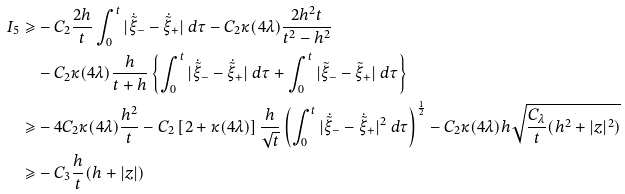<formula> <loc_0><loc_0><loc_500><loc_500>I _ { 5 } \geqslant & - C _ { 2 } \frac { 2 h } t \int ^ { t } _ { 0 } | \dot { \tilde { \xi } } _ { - } - \dot { \tilde { \xi } } _ { + } | \ d \tau - C _ { 2 } \kappa ( 4 \lambda ) \frac { 2 h ^ { 2 } t } { t ^ { 2 } - h ^ { 2 } } \\ & - C _ { 2 } \kappa ( 4 \lambda ) \frac { h } { t + h } \left \{ \int ^ { t } _ { 0 } | \dot { \tilde { \xi } } _ { - } - \dot { \tilde { \xi } } _ { + } | \ d \tau + \int ^ { t } _ { 0 } | \tilde { \xi } _ { - } - \tilde { \xi } _ { + } | \ d \tau \right \} \\ \geqslant & - 4 C _ { 2 } \kappa ( 4 \lambda ) \frac { h ^ { 2 } } { t } - C _ { 2 } \left [ 2 + \kappa ( 4 \lambda ) \right ] \frac { h } { \sqrt { t } } \left ( \int ^ { t } _ { 0 } | \dot { \tilde { \xi } } _ { - } - \dot { \tilde { \xi } } _ { + } | ^ { 2 } \ d \tau \right ) ^ { \frac { 1 } { 2 } } - C _ { 2 } \kappa ( 4 \lambda ) h \sqrt { \frac { C _ { \lambda } } t ( h ^ { 2 } + | z | ^ { 2 } ) } \\ \geqslant & - C _ { 3 } \frac { h } t ( h + | z | )</formula> 